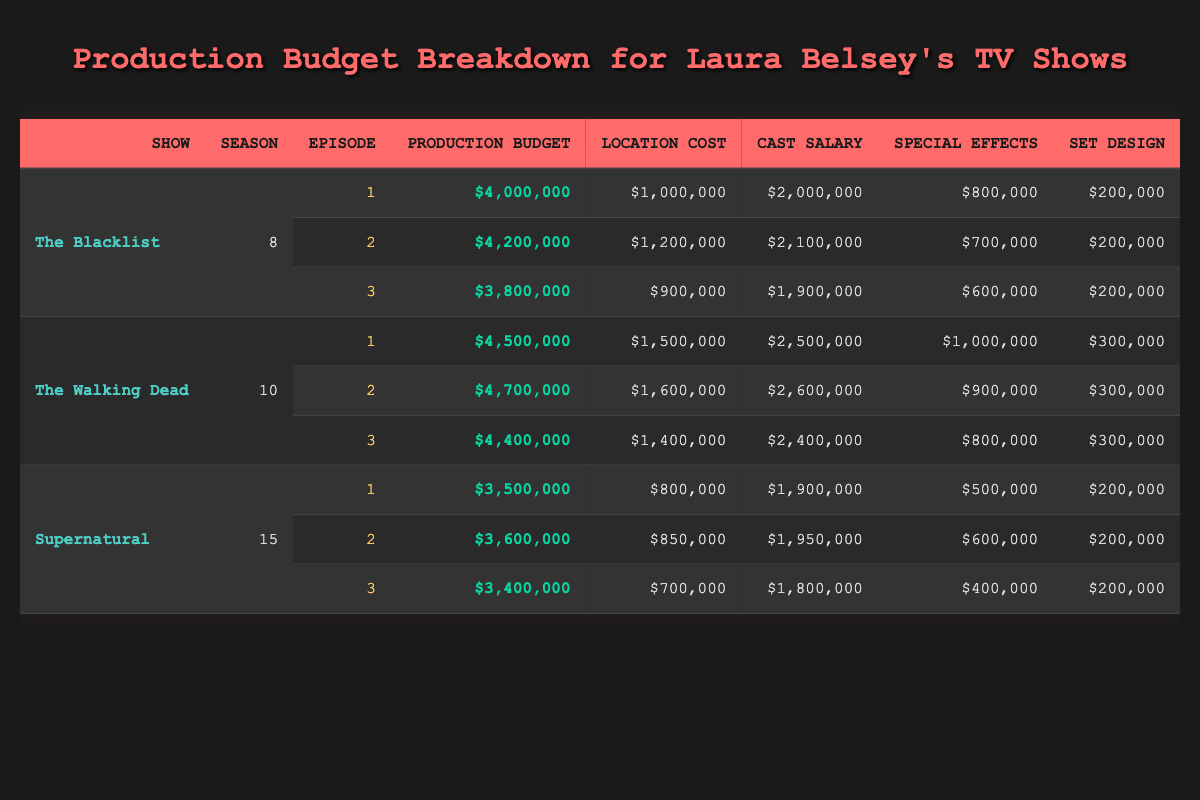What is the production budget for Episode 2 of The Blacklist? The production budget for Episode 2 of The Blacklist is listed directly in the table as $4,200,000.
Answer: $4,200,000 What is the location cost for Episode 3 of The Walking Dead? The location cost for Episode 3 of The Walking Dead is given as $1,400,000 directly in the table.
Answer: $1,400,000 Is the production budget for Episode 1 of Supernatural less than that of Episode 3? The production budget for Episode 1 of Supernatural is $3,500,000, while for Episode 3 it is $3,400,000. Since $3,500,000 is greater than $3,400,000, the statement is false.
Answer: No What is the total production budget for all episodes of The Walking Dead? The production budgets for the episodes of The Walking Dead are $4,500,000, $4,700,000, and $4,400,000. Adding these gives: $4,500,000 + $4,700,000 + $4,400,000 = $13,600,000.
Answer: $13,600,000 What is the average cast salary for all episodes of The Blacklist? The cast salaries for The Blacklist's episodes are $2,000,000, $2,100,000, and $1,900,000. To find the average, first sum them up: $2,000,000 + $2,100,000 + $1,900,000 = $6,000,000, then divide by 3 (the number of episodes): $6,000,000 / 3 = $2,000,000.
Answer: $2,000,000 Which episode has the highest special effects cost in Supernatural? The special effects costs for Supernatural are $500,000 for Episode 1, $600,000 for Episode 2, and $400,000 for Episode 3. The highest is $600,000 for Episode 2.
Answer: Episode 2 Is the total cost of location in The Walking Dead higher than in The Blacklist? The total location costs for The Walking Dead are $1,500,000 + $1,600,000 + $1,400,000 = $4,500,000. In comparison, The Blacklist has $1,000,000 + $1,200,000 + $900,000 = $3,100,000. Since $4,500,000 is greater than $3,100,000, the answer is yes.
Answer: Yes What is the difference in production budget between Episode 1 and Episode 3 of The Walking Dead? The production budget for Episode 1 of The Walking Dead is $4,500,000 and for Episode 3 it is $4,400,000. The difference is $4,500,000 - $4,400,000 = $100,000.
Answer: $100,000 Identify the show with the highest total production budget. The total production budgets for the shows are: The Blacklist $12,600,000, The Walking Dead $13,600,000, and Supernatural $10,500,000. The highest total is for The Walking Dead at $13,600,000.
Answer: The Walking Dead 